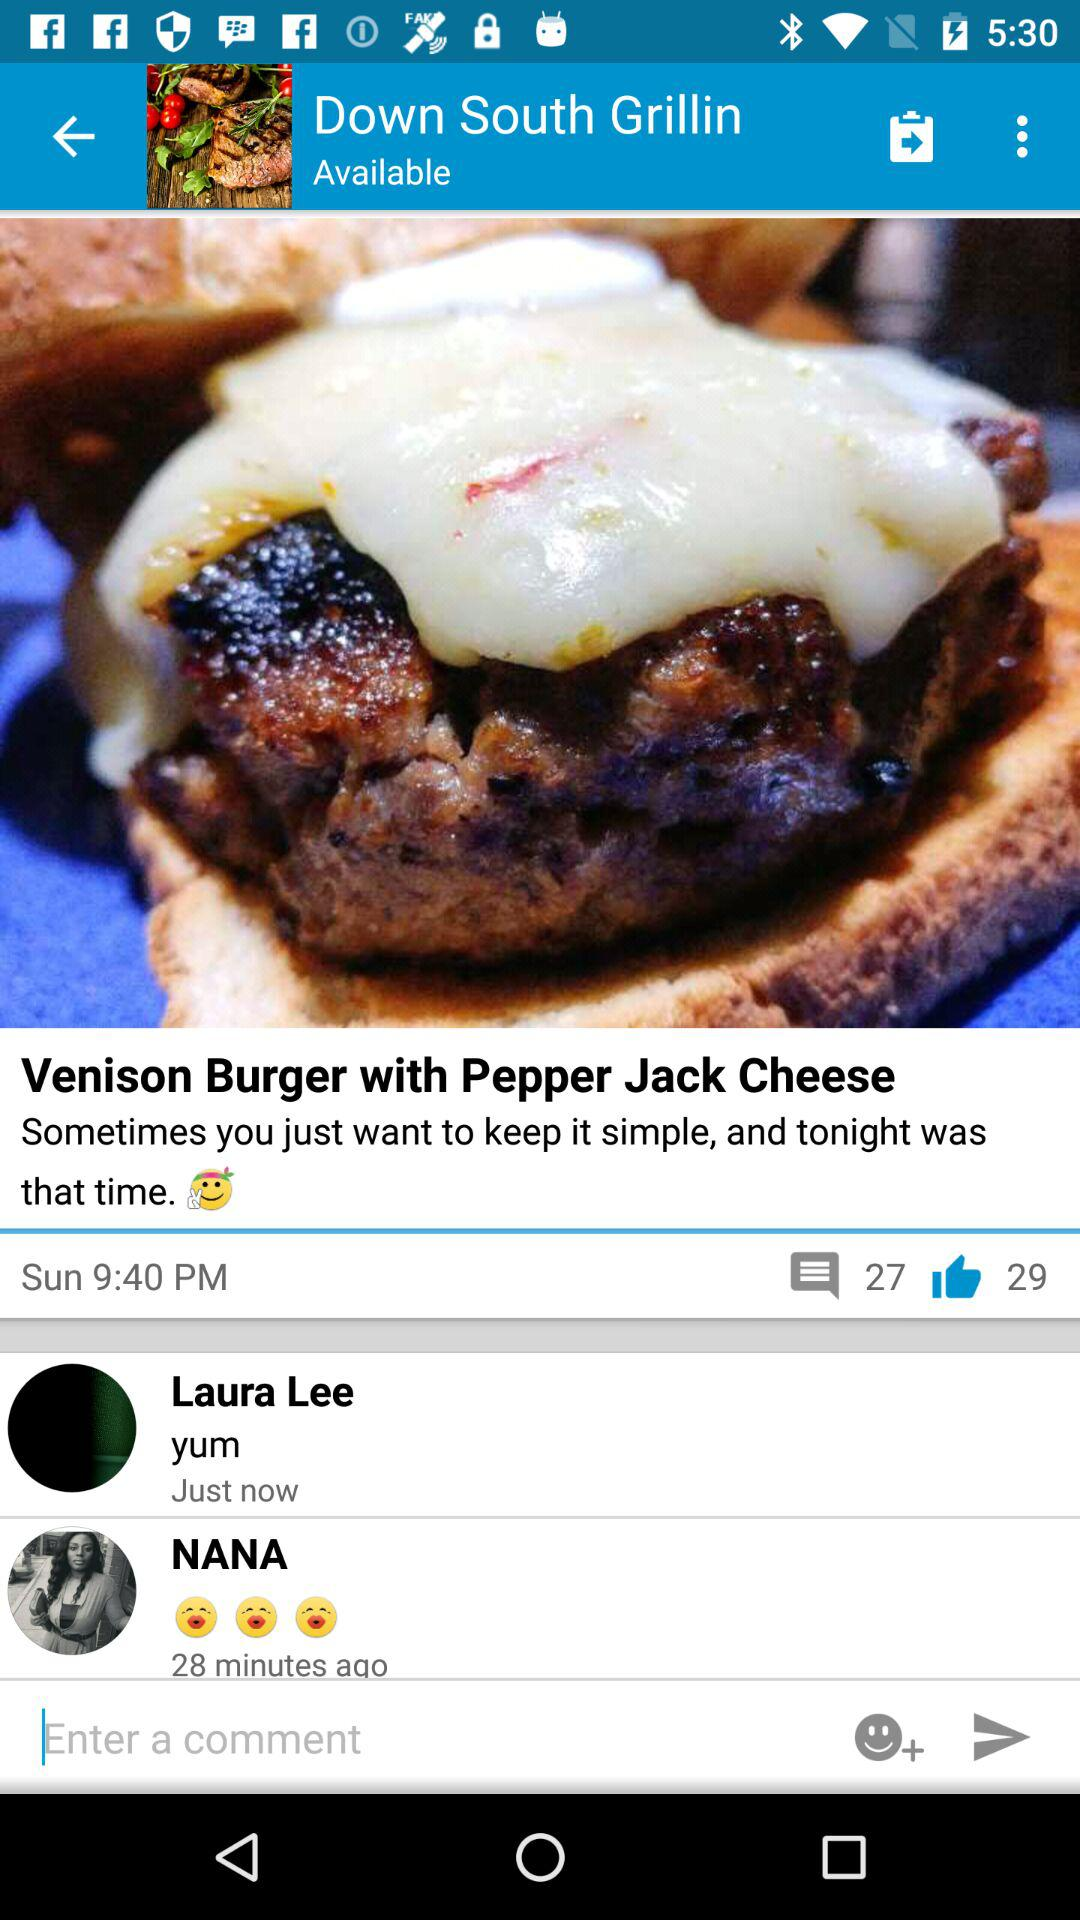What is the current location?
When the provided information is insufficient, respond with <no answer>. <no answer> 